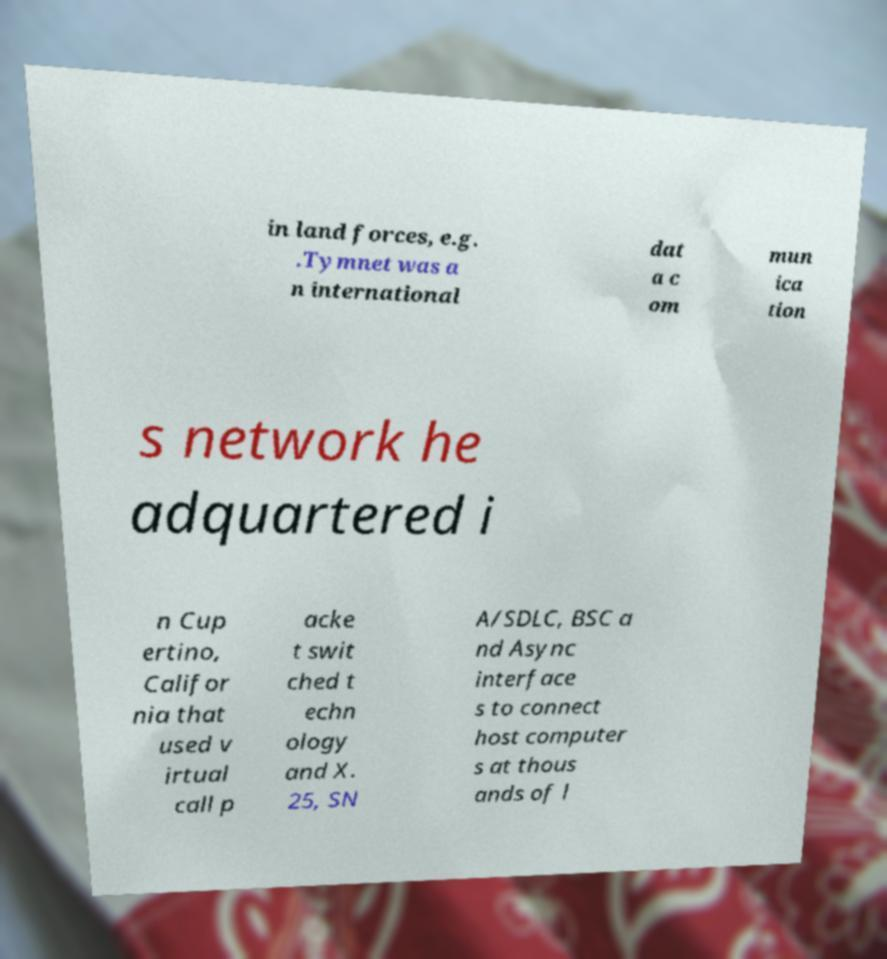There's text embedded in this image that I need extracted. Can you transcribe it verbatim? in land forces, e.g. .Tymnet was a n international dat a c om mun ica tion s network he adquartered i n Cup ertino, Califor nia that used v irtual call p acke t swit ched t echn ology and X. 25, SN A/SDLC, BSC a nd Async interface s to connect host computer s at thous ands of l 